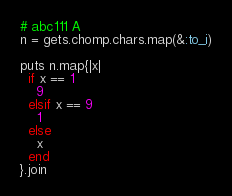<code> <loc_0><loc_0><loc_500><loc_500><_Ruby_># abc111 A
n = gets.chomp.chars.map(&:to_i)

puts n.map{|x|
  if x == 1
    9
  elsif x == 9
    1
  else
    x
  end
}.join


</code> 